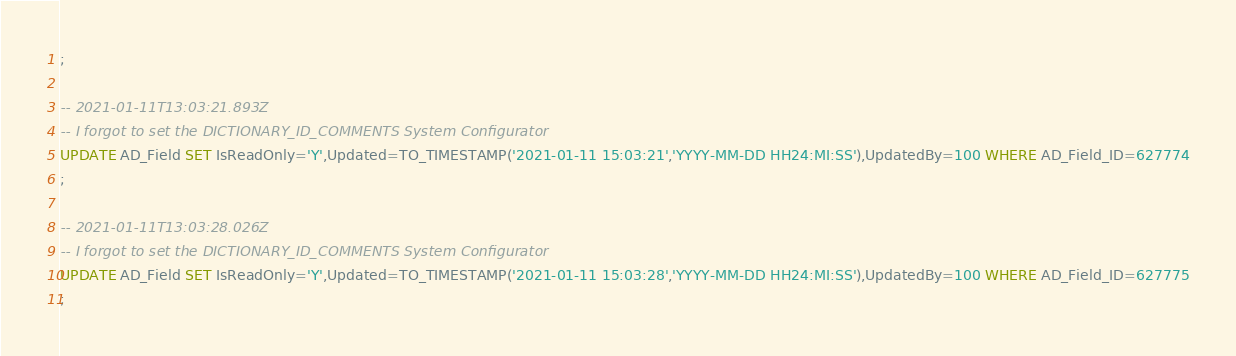Convert code to text. <code><loc_0><loc_0><loc_500><loc_500><_SQL_>;

-- 2021-01-11T13:03:21.893Z
-- I forgot to set the DICTIONARY_ID_COMMENTS System Configurator
UPDATE AD_Field SET IsReadOnly='Y',Updated=TO_TIMESTAMP('2021-01-11 15:03:21','YYYY-MM-DD HH24:MI:SS'),UpdatedBy=100 WHERE AD_Field_ID=627774
;

-- 2021-01-11T13:03:28.026Z
-- I forgot to set the DICTIONARY_ID_COMMENTS System Configurator
UPDATE AD_Field SET IsReadOnly='Y',Updated=TO_TIMESTAMP('2021-01-11 15:03:28','YYYY-MM-DD HH24:MI:SS'),UpdatedBy=100 WHERE AD_Field_ID=627775
;

</code> 